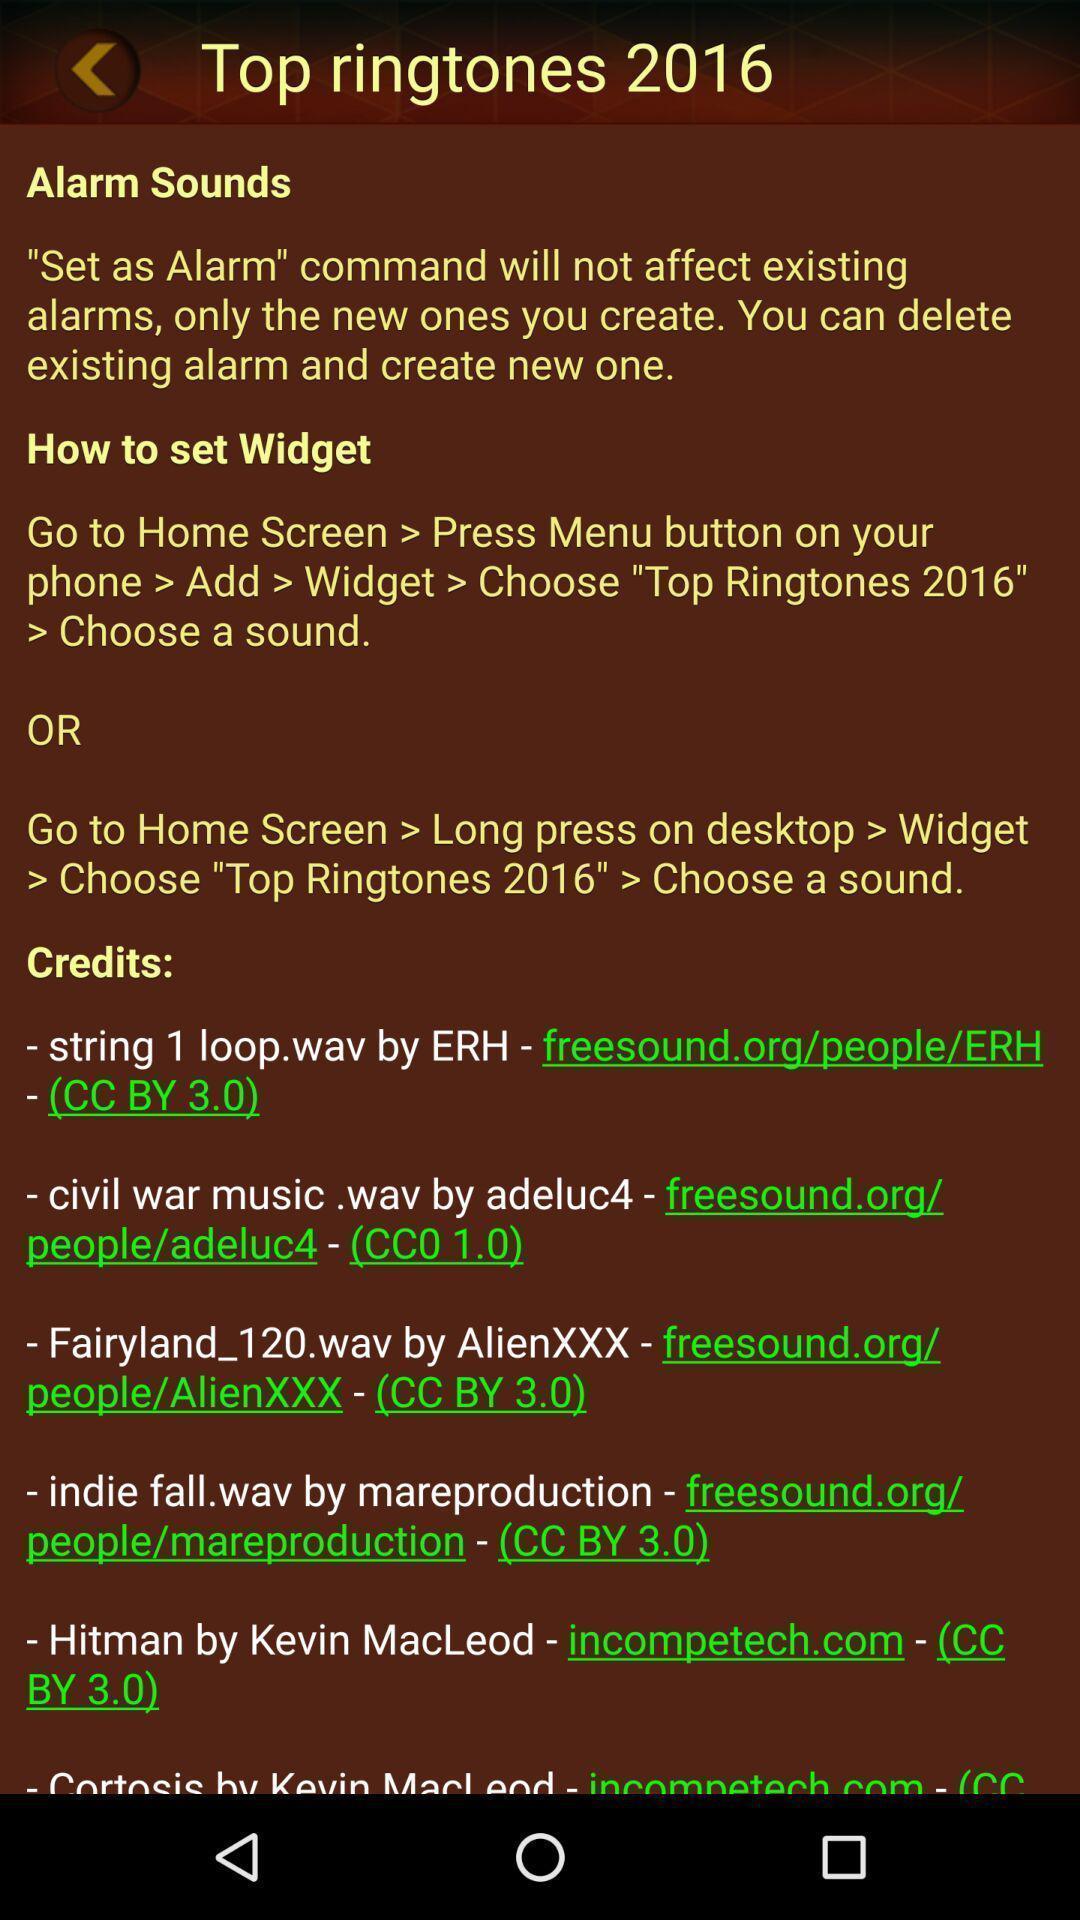Explain the elements present in this screenshot. Page showing different top ringtones. 